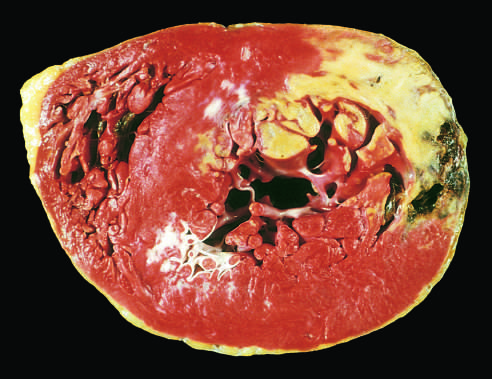s acute myocardial infarct of the posterolateral left ventricle demonstrated by a lack of triphenyltetrazolium chloride staining in areas of necrosis?
Answer the question using a single word or phrase. Yes 